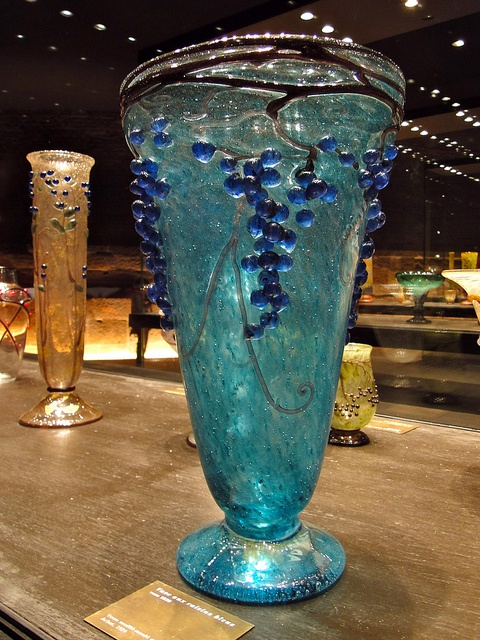Describe the objects in this image and their specific colors. I can see vase in black and teal tones, vase in black, brown, tan, and maroon tones, vase in black, olive, and tan tones, wine glass in black, darkgreen, green, and olive tones, and wine glass in black, lightyellow, khaki, tan, and maroon tones in this image. 